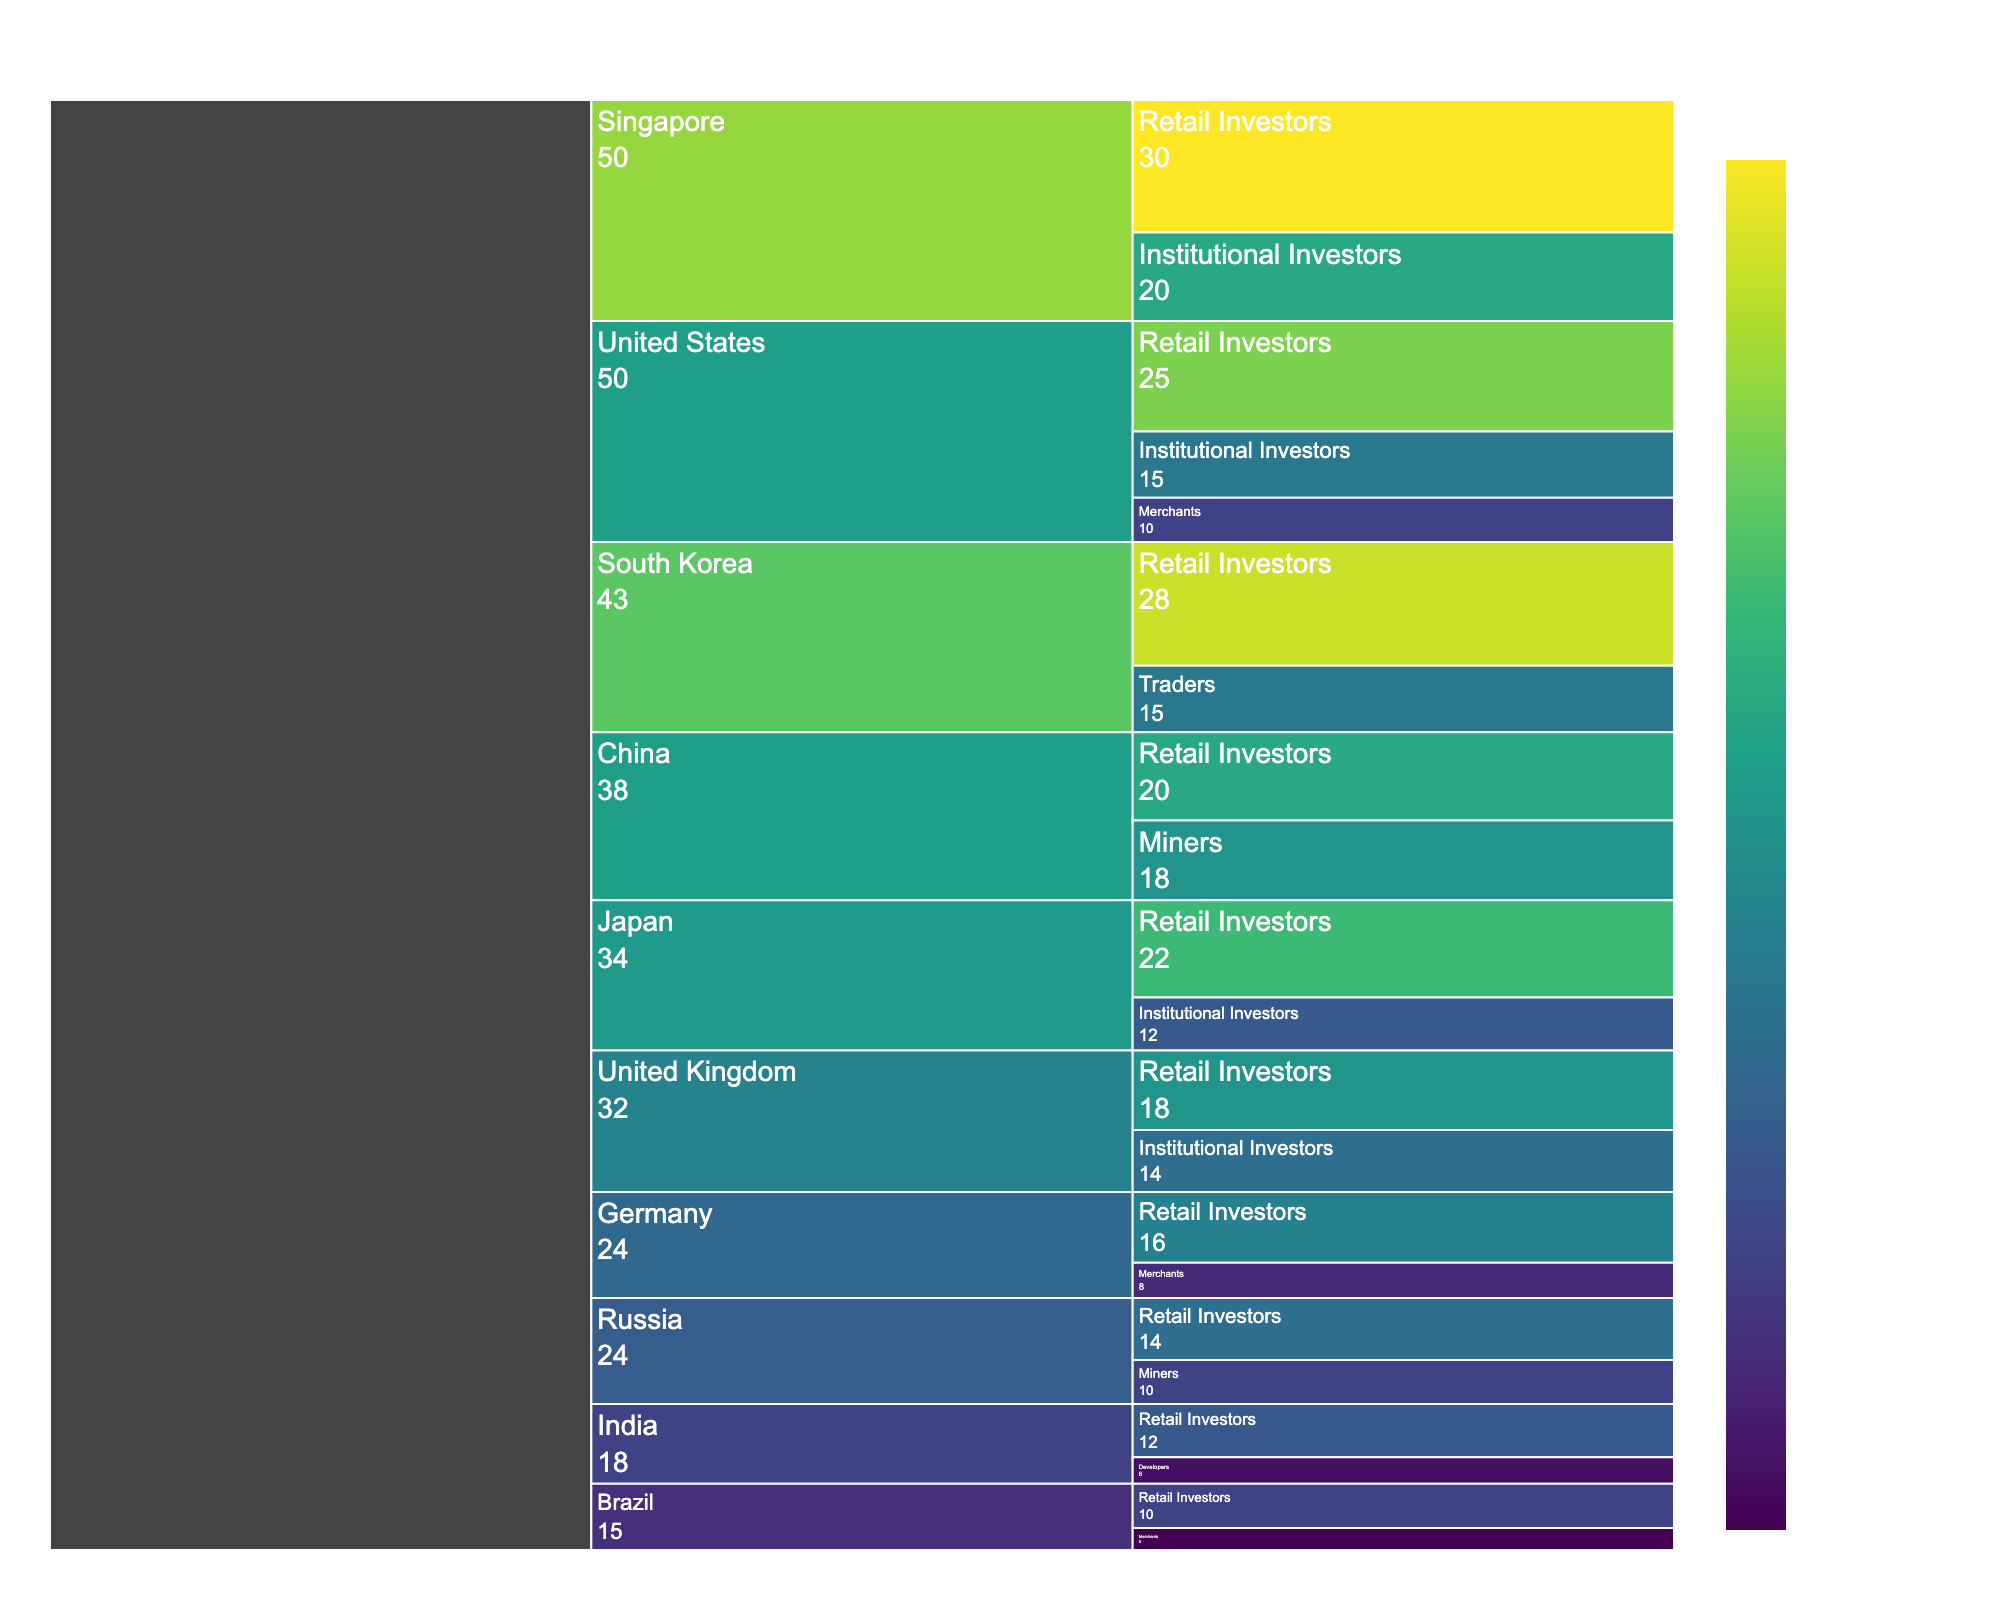What's the title of the Icicle Chart? The title is displayed at the top of the chart, which summarizes the main topic of the visualization. The title in this case is "Global Cryptocurrency Adoption Rates by Country and User Type".
Answer: Global Cryptocurrency Adoption Rates by Country and User Type Which country has the highest adoption rate in the Retail Investors category? By observing the segments under the 'Retail Investors' branch, we can see which country has the highest value. South Korea has the highest adoption rate at 28%.
Answer: South Korea What is the combined adoption rate for Institutional Investors in the United States and Singapore? The adoption rate for Institutional Investors in the United States is 15% and in Singapore is 20%. The combined rate is obtained by adding these two values: 15 + 20 = 35%.
Answer: 35% Compare the adoption rates of Merchants in the United States and Germany. Which one is higher and by how much? The adoption rate for Merchants in the United States is 10%, and in Germany, it is 8%. The difference is calculated as 10 - 8 = 2%. Therefore, the US has a higher adoption rate by 2%.
Answer: United States by 2% How many user types are categorized under South Korea, and what are they? In the icicle chart, we can count the branches under the 'South Korea' segment. There are 2 user types: Retail Investors and Traders.
Answer: 2 user types (Retail Investors, Traders) What is the adoption rate difference between Retail Investors in Japan and Retail Investors in Russia? The adoption rate for Retail Investors in Japan is 22% and in Russia is 14%. Subtract the smaller rate from the larger one to find the difference: 22 - 14 = 8%.
Answer: 8% What color indicates the highest adoption rate in the chart, and which user type and country does it represent? The color scale in the chart ranges from light to dark, representing lower to higher adoption rates, respectively. The darkest color, which corresponds to the highest adoption rate, is observed for Retail Investors in Singapore with a rate of 30%.
Answer: Dark color, Retail Investors in Singapore Which country has the lowest adoption rate for Developers, and what is the rate? Checking the sections labeled as 'Developers', we find only India under this category with a rate of 6%, which is also the lowest since it is the only one.
Answer: India, 6% What is the total adoption rate for Retail Investors across all countries? Add the adoption rates for Retail Investors from all countries: 25 (US) + 20 (China) + 22 (Japan) + 28 (South Korea) + 18 (UK) + 16 (Germany) + 12 (India) + 30 (Singapore) + 14 (Russia) + 10 (Brazil) = 195%.
Answer: 195% What user type has the second highest adoption rate in the United States, and what is the rate? In the United States segment, the user types and their rates are: Retail Investors (25), Institutional Investors (15), and Merchants (10). The second highest rate is for Institutional Investors at 15%.
Answer: Institutional Investors, 15% 